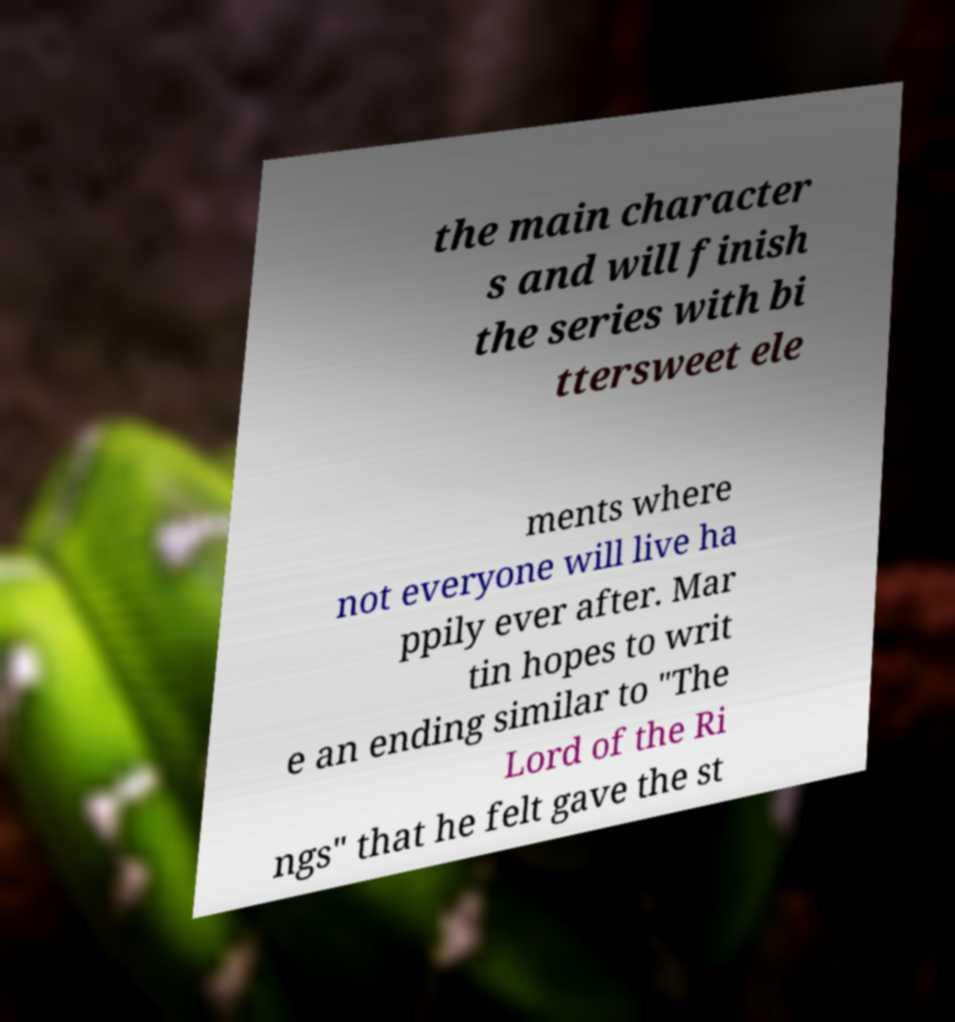I need the written content from this picture converted into text. Can you do that? the main character s and will finish the series with bi ttersweet ele ments where not everyone will live ha ppily ever after. Mar tin hopes to writ e an ending similar to "The Lord of the Ri ngs" that he felt gave the st 